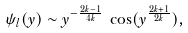<formula> <loc_0><loc_0><loc_500><loc_500>\psi _ { l } ( y ) \sim y ^ { - \frac { 2 k - 1 } { 4 k } } \, \cos ( y ^ { \frac { 2 k + 1 } { 2 k } } ) ,</formula> 